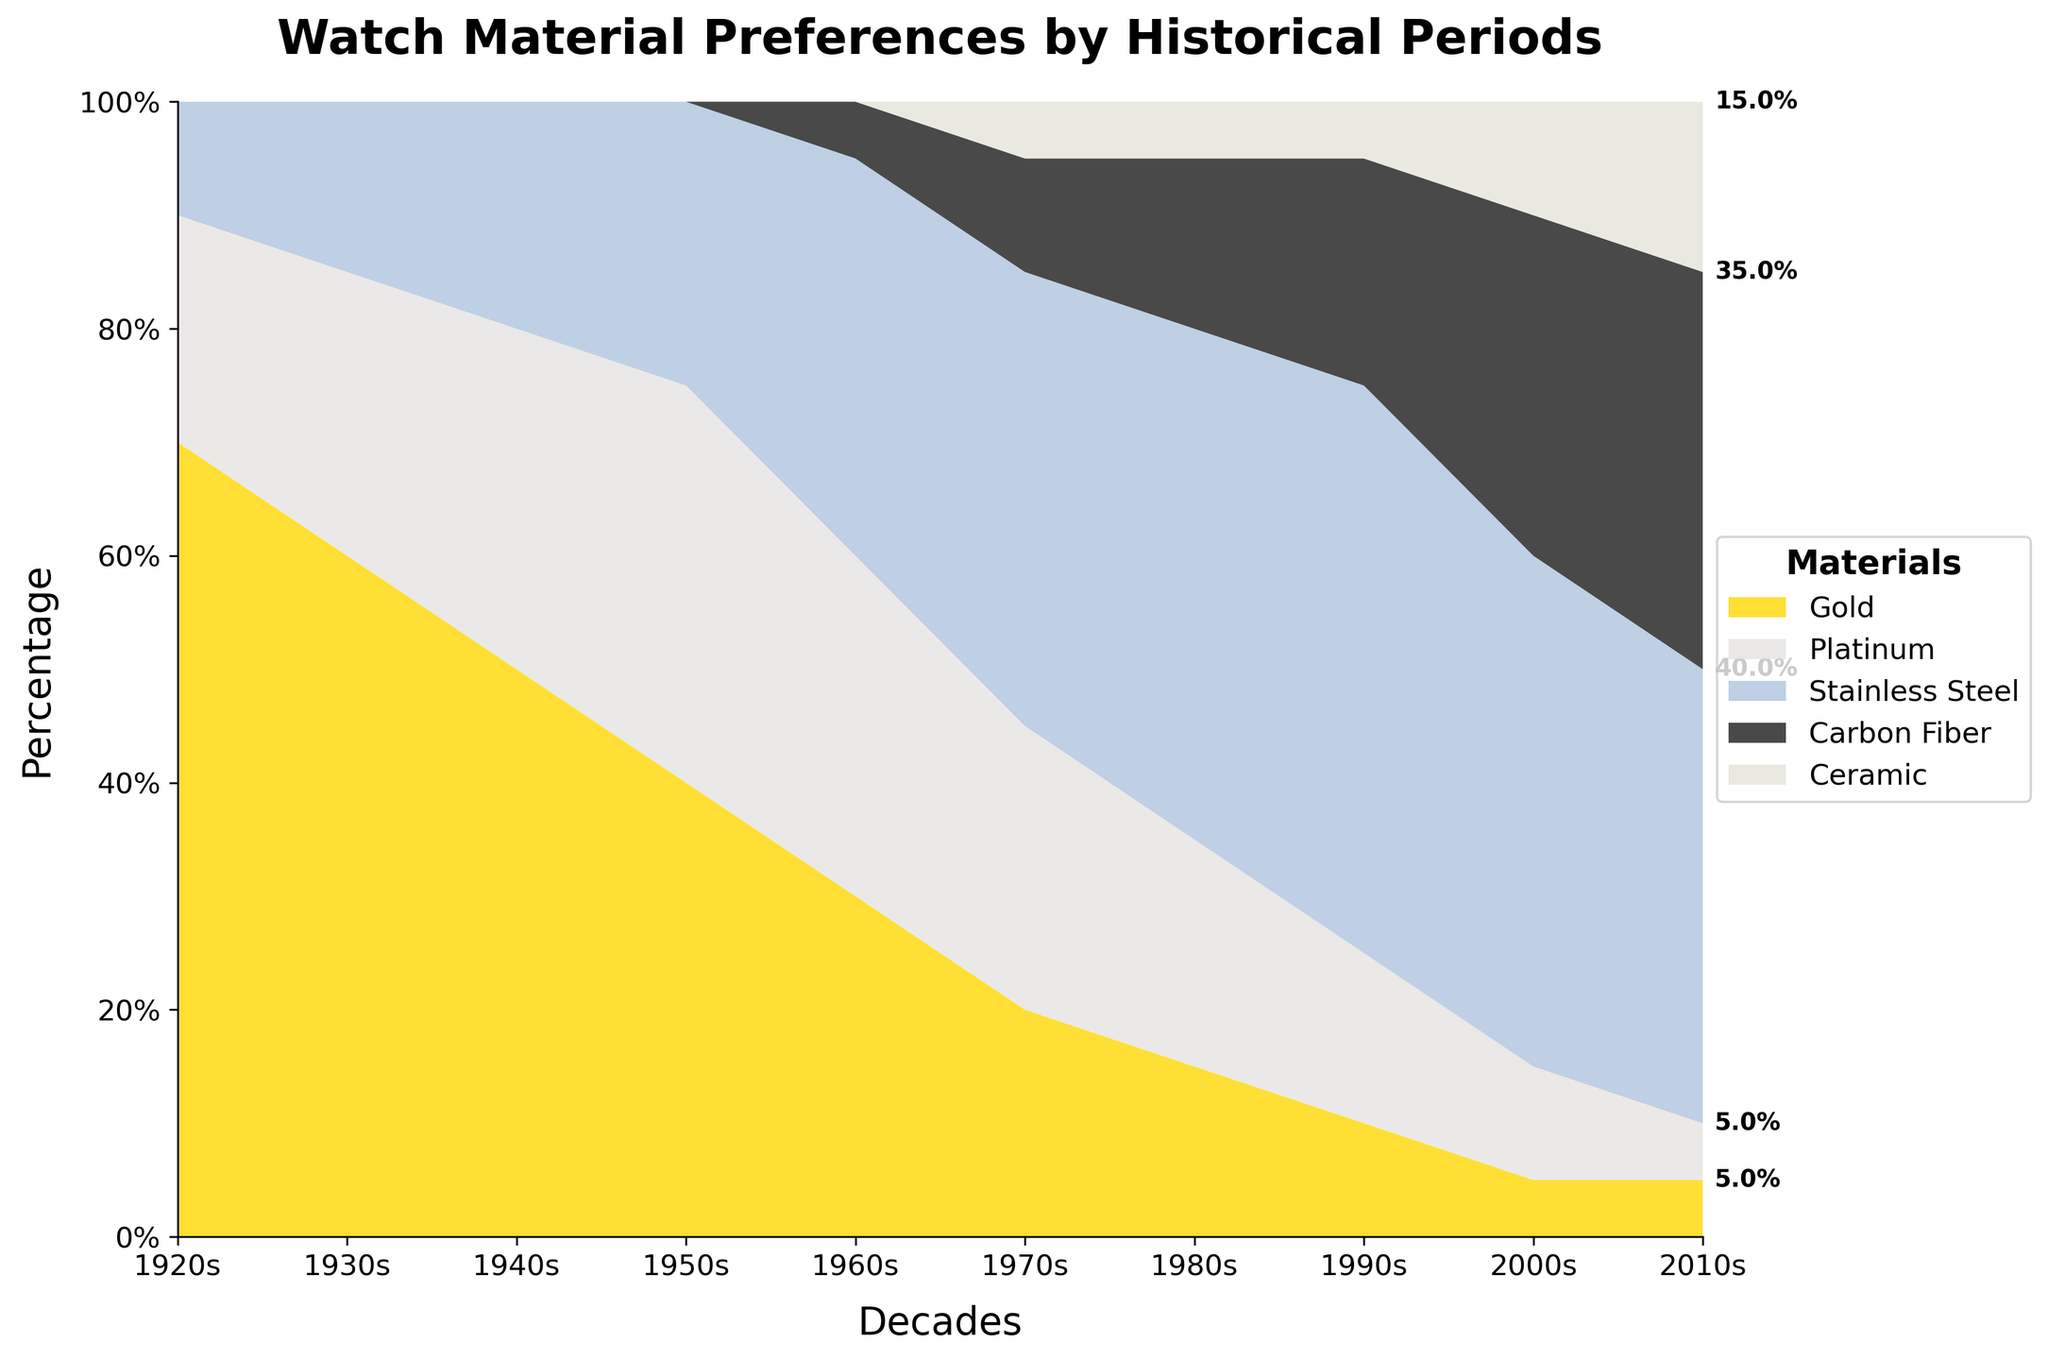What are the time periods covered in the chart? The x-axis of the chart shows the decades, starting from the 1920s to the 2010s. The periods displayed are 1920s, 1930s, 1940s, 1950s, 1960s, 1970s, 1980s, 1990s, 2000s, and 2010s.
Answer: 1920s to 2010s What material had the highest preference in the 1920s? By examining the height of the stacked areas in the 1920s on the chart, it is clear that the gold section is the tallest. This indicates that gold was the most preferred material in the 1920s.
Answer: Gold How did the preference for gold change from the 1920s to the 2010s? In the 1920s, the preference for gold was at its highest, taking up 70% of the percentage stack. Over the decades, this preference continually decreased, reaching just 5% in the 2010s.
Answer: Decreased from 70% to 5% Which materials were first introduced in the 1960s? Observing the chart, only gold, platinum, and stainless steel were present before the 1960s. In the 1960s, new colors start appearing for carbon fiber indicating its initial appearance.
Answer: Carbon Fiber In which decade did stainless steel become the most preferred material? Looking at the chart, each material's prominence, as indicated by the largest stacked area segment, is stainless steel in the 1990s, covering the highest percentage.
Answer: 1990s By how much did the combined preference for carbon fiber and ceramic increase from the 2000s to 2010s? In the 2000s, carbon fiber had 30% and ceramic had 10%, totaling 40%. In the 2010s, carbon fiber had 35% and ceramic had 15%, totaling 50%. The increase is 50% - 40% = 10%.
Answer: 10% Which decade shows the smallest preference for gold and platinum combined? Analyzing the chart, the smallest combined area for gold and platinum together appears in the 2010s where gold is 5% and platinum is 5%, summing up to 10%.
Answer: 2010s What is the trend in preference for ceramic watches from the time it was introduced to the latest period? Ceramic appears in the 1970s at 5% and remains flat until the 1990s. From the 2000s, ceramic preference increased to 10% and then to 15% in the 2010s, indicating an upward trend.
Answer: Increasing Which material had a preference of 45% in two different decades, and what were those periods? Observing the chart, stainless steel had a 45% preference in both the 1980s and the 2000s.
Answer: Stainless Steel; 1980s and 2000s What was the exact percentage of platinum preference in the 1950s and how does it compare to gold in the same decade? The chart shows platinum at 35% in the 1950s. In the same period, gold was at 40%. Comparing them, gold was preferred by a slight margin of 5%.
Answer: Platinum 35%, Gold 40%. Gold preferred by 5% more 